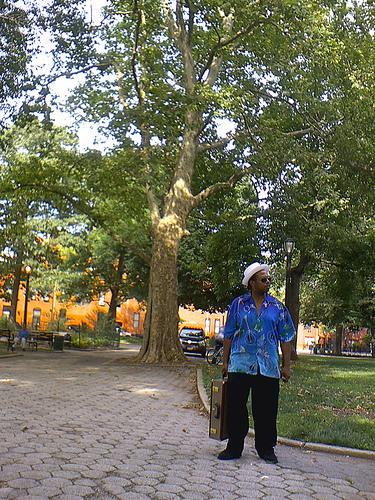Question: where was this picture taken?
Choices:
A. The beach.
B. At a park.
C. A restaurant.
D. The mountain.
Answer with the letter. Answer: B Question: where is the car?
Choices:
A. The parking lot.
B. The driveway.
C. The street.
D. Behind the large tree.
Answer with the letter. Answer: D Question: what is in the man's hand?
Choices:
A. A baby.
B. A suitcase.
C. A ball.
D. A dog.
Answer with the letter. Answer: B 